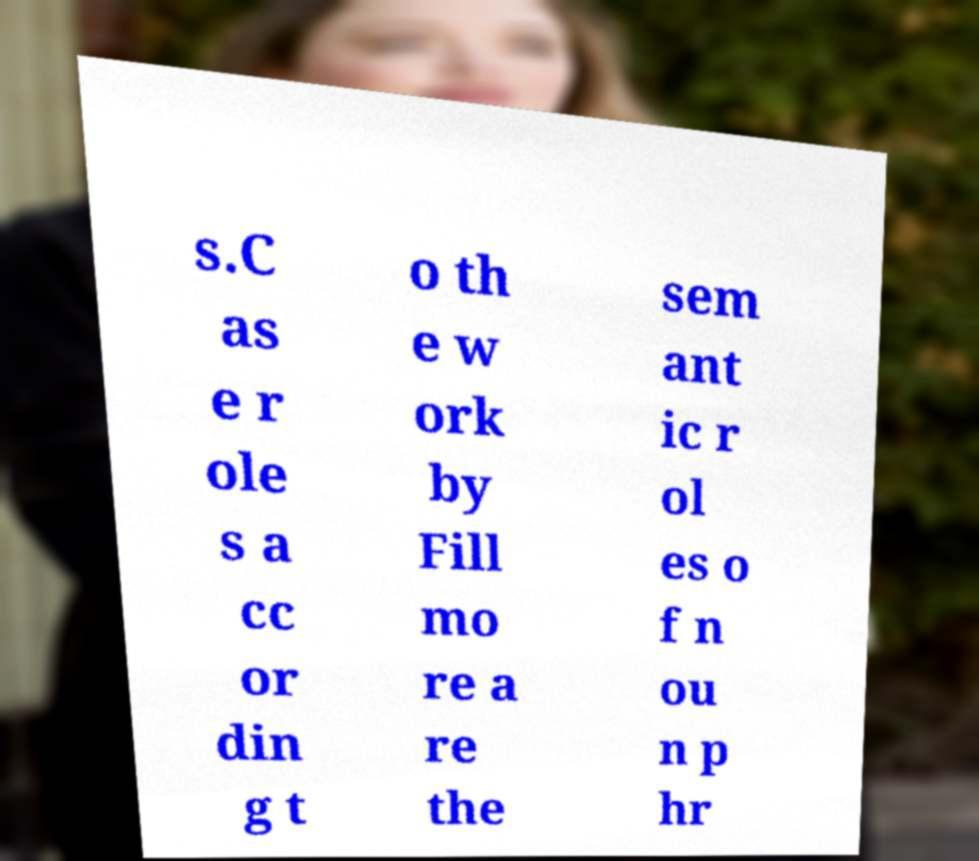Could you extract and type out the text from this image? s.C as e r ole s a cc or din g t o th e w ork by Fill mo re a re the sem ant ic r ol es o f n ou n p hr 